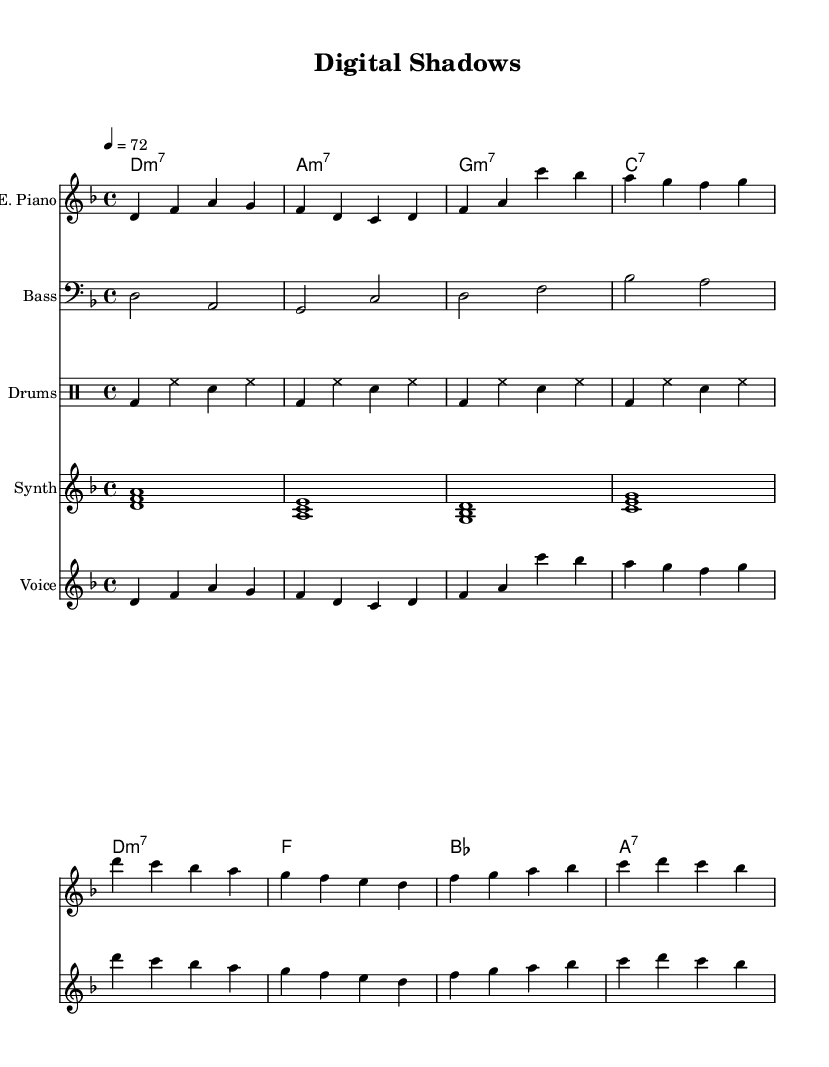What is the key signature of this music? The key signature is indicated in the global settings line, which specifies D minor, denoted by one flat.
Answer: D minor What is the time signature of this piece? The time signature is also specified in the global settings, which is 4/4, indicating four beats per measure.
Answer: 4/4 What is the tempo of the music? The tempo is defined in the global settings as quarter note equal to seventy-two beats per minute.
Answer: 72 How many measures are there in the verse? The verse is structured in a specific pattern, and counting the groupings, there are eight measures total in the verse section.
Answer: 8 What is the name of the instrument for the melody? The instrument specified for the melody is the voice, as indicated by the label in the staff section.
Answer: Voice What type of chords are used in the verse? The chords in the verse are specifically indicated as minor 7th chords, referred to by the notation for D minor 7th, A minor 7th, G minor 7th, and C7.
Answer: Minor 7th How does the rhythm of the voice part compare to the electric piano? The voice part and the electric piano part have the same rhythmic pattern; they both follow the same note values and placement within the measures.
Answer: Same 